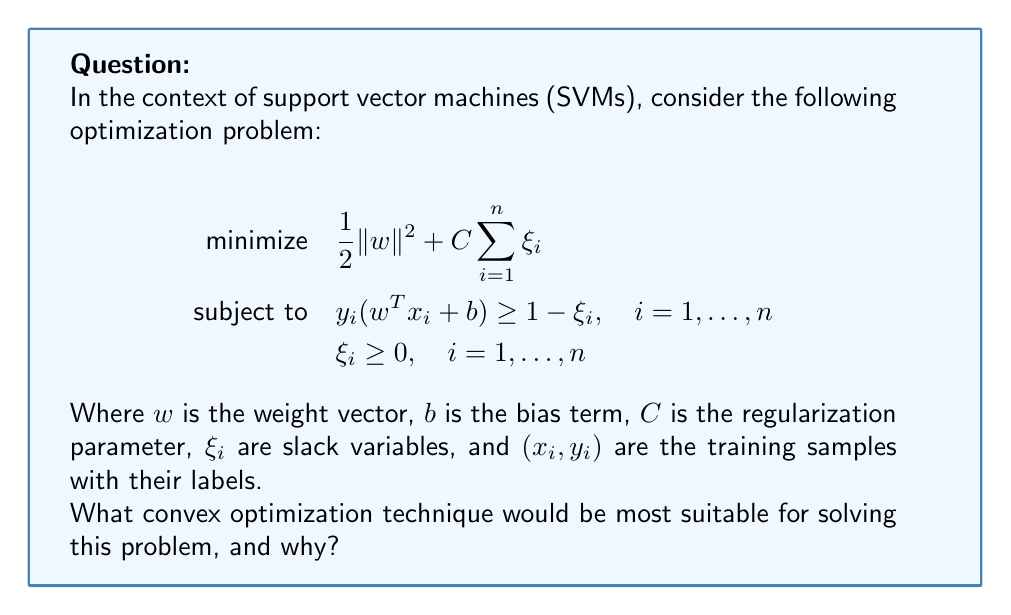Can you answer this question? To determine the most suitable convex optimization technique for this SVM problem, let's analyze its characteristics:

1. Objective function:
   The objective function $\frac{1}{2}\|w\|^2 + C\sum_{i=1}^n \xi_i$ is convex, as it's the sum of two convex functions:
   - $\frac{1}{2}\|w\|^2$ is a quadratic function (convex)
   - $C\sum_{i=1}^n \xi_i$ is a linear function (convex)

2. Constraints:
   - The constraints $y_i(w^T x_i + b) \geq 1 - \xi_i$ are linear inequalities
   - The constraints $\xi_i \geq 0$ are also linear inequalities

3. Problem structure:
   This problem has a convex objective function with linear inequality constraints, which makes it a convex quadratic programming (QP) problem.

4. Problem size:
   In machine learning applications, the number of training samples $n$ can be very large, potentially leading to a high-dimensional optimization problem.

5. Characteristics of SVM:
   SVMs typically result in sparse solutions, where many of the slack variables $\xi_i$ are zero.

Given these characteristics, the most suitable convex optimization technique for this problem would be the Sequential Minimal Optimization (SMO) algorithm. Here's why:

1. SMO is specifically designed for SVM optimization problems.
2. It breaks down the large QP problem into a series of smallest possible sub-problems, which can be solved analytically.
3. SMO takes advantage of the sparsity of the SVM solution.
4. It's memory efficient, as it doesn't require storing the entire Hessian matrix.
5. SMO scales well to large datasets, which is common in machine learning applications.

Other techniques like Interior Point Methods or general-purpose QP solvers could also be used, but they may not be as efficient for large-scale SVM problems.
Answer: Sequential Minimal Optimization (SMO) algorithm 